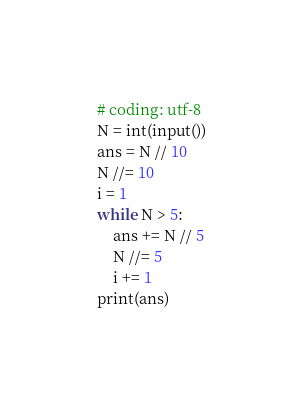<code> <loc_0><loc_0><loc_500><loc_500><_Python_># coding: utf-8
N = int(input())
ans = N // 10
N //= 10
i = 1
while N > 5:
    ans += N // 5
    N //= 5
    i += 1
print(ans)</code> 